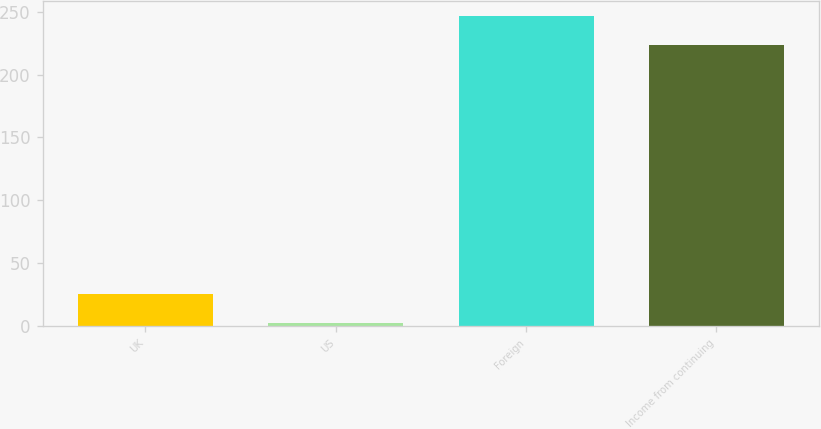Convert chart to OTSL. <chart><loc_0><loc_0><loc_500><loc_500><bar_chart><fcel>UK<fcel>US<fcel>Foreign<fcel>Income from continuing<nl><fcel>25.37<fcel>2.3<fcel>246.17<fcel>223.1<nl></chart> 